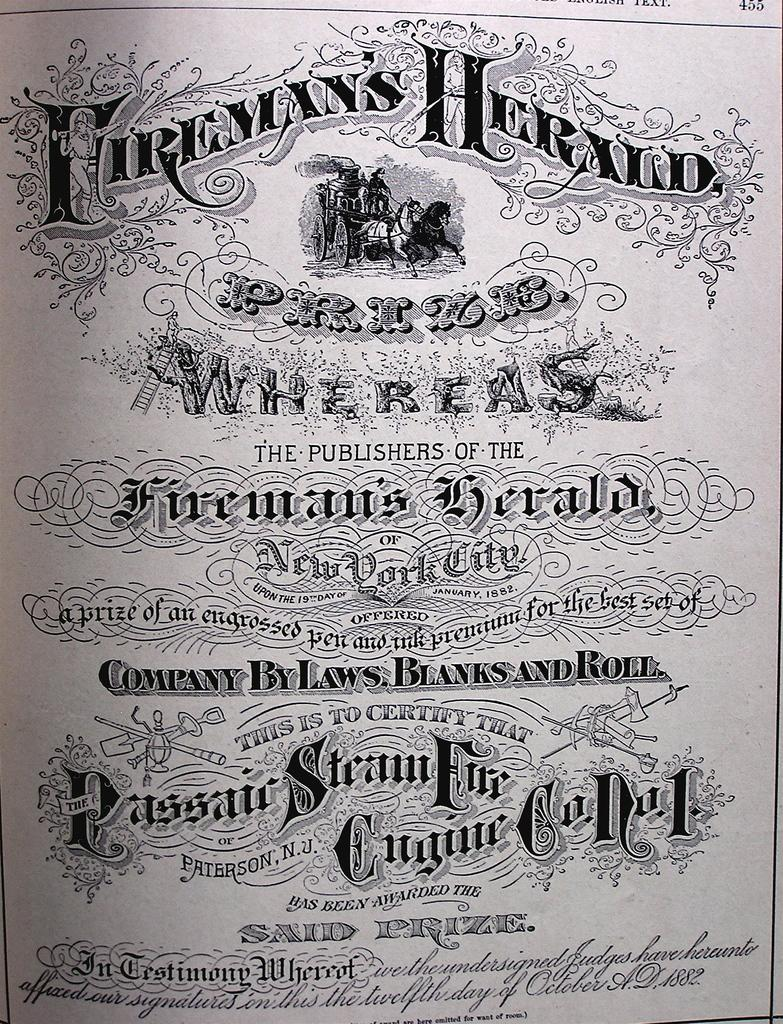<image>
Relay a brief, clear account of the picture shown. A cover page of company by laws for Blanks and Roll. 